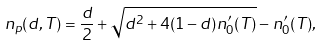Convert formula to latex. <formula><loc_0><loc_0><loc_500><loc_500>n _ { p } ( d , T ) = \frac { d } { 2 } + \sqrt { d ^ { 2 } + 4 ( 1 - d ) n ^ { \prime } _ { 0 } ( T ) } - n ^ { \prime } _ { 0 } ( T ) ,</formula> 